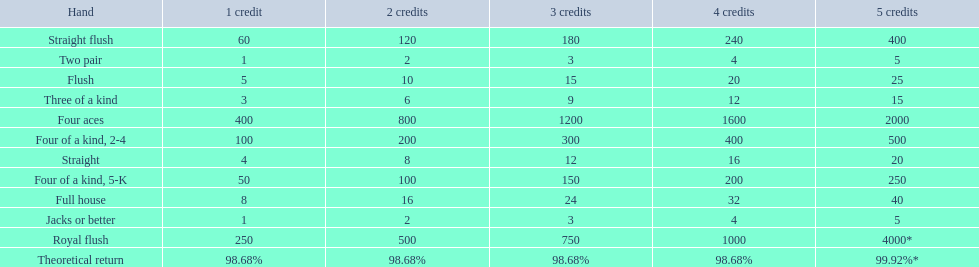What are the hands in super aces? Royal flush, Straight flush, Four aces, Four of a kind, 2-4, Four of a kind, 5-K, Full house, Flush, Straight, Three of a kind, Two pair, Jacks or better. What hand gives the highest credits? Royal flush. 